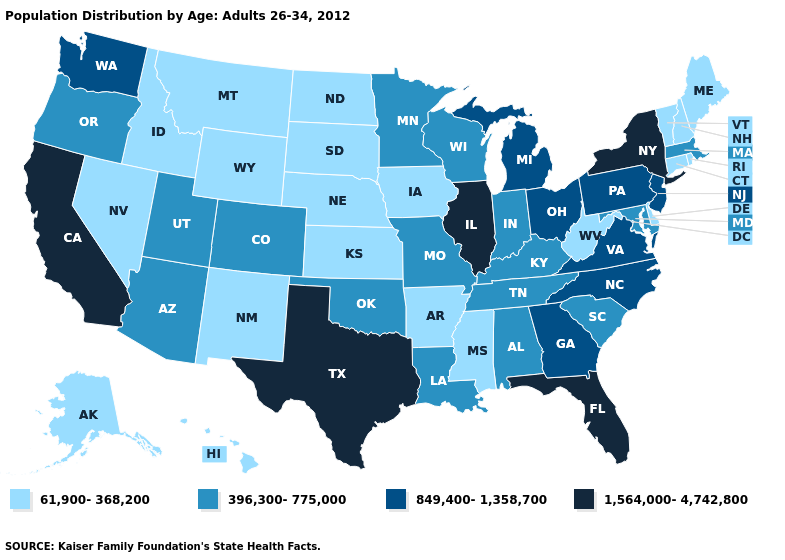What is the value of Illinois?
Be succinct. 1,564,000-4,742,800. What is the highest value in states that border Texas?
Short answer required. 396,300-775,000. Name the states that have a value in the range 1,564,000-4,742,800?
Be succinct. California, Florida, Illinois, New York, Texas. Does the map have missing data?
Answer briefly. No. Which states have the lowest value in the USA?
Write a very short answer. Alaska, Arkansas, Connecticut, Delaware, Hawaii, Idaho, Iowa, Kansas, Maine, Mississippi, Montana, Nebraska, Nevada, New Hampshire, New Mexico, North Dakota, Rhode Island, South Dakota, Vermont, West Virginia, Wyoming. What is the value of Arizona?
Short answer required. 396,300-775,000. Does Florida have the highest value in the USA?
Write a very short answer. Yes. Does Illinois have the same value as South Carolina?
Be succinct. No. Name the states that have a value in the range 849,400-1,358,700?
Give a very brief answer. Georgia, Michigan, New Jersey, North Carolina, Ohio, Pennsylvania, Virginia, Washington. What is the value of North Dakota?
Give a very brief answer. 61,900-368,200. Among the states that border Missouri , which have the highest value?
Short answer required. Illinois. Name the states that have a value in the range 1,564,000-4,742,800?
Keep it brief. California, Florida, Illinois, New York, Texas. Among the states that border West Virginia , does Virginia have the lowest value?
Keep it brief. No. Name the states that have a value in the range 1,564,000-4,742,800?
Concise answer only. California, Florida, Illinois, New York, Texas. What is the value of Virginia?
Short answer required. 849,400-1,358,700. 